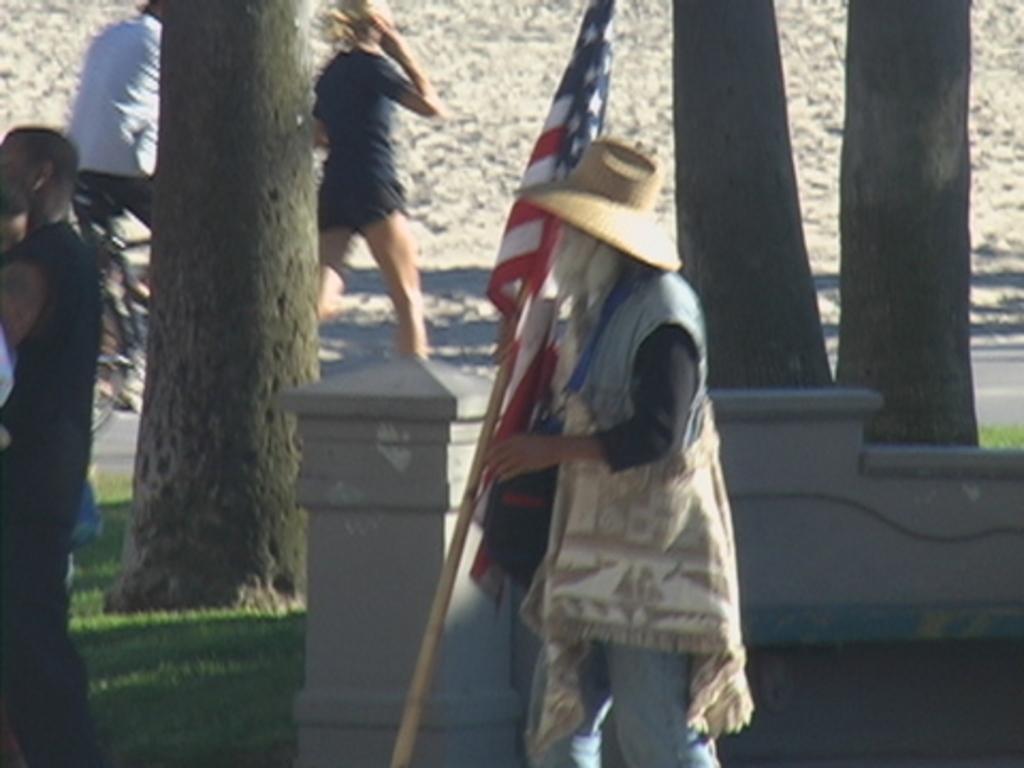How would you summarize this image in a sentence or two? Here I can see a person wearing a jacket, cap on the head, holding a flag in the hand and walking towards the left side. On the left side there is a man standing and carrying a baby. Behind this man there is a wall. In the background there are tree trunks and a woman is walking and also there is a person riding a bicycle. 